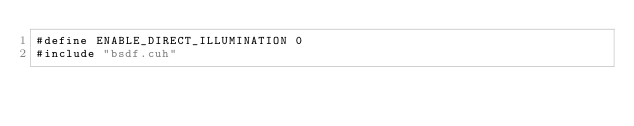Convert code to text. <code><loc_0><loc_0><loc_500><loc_500><_Cuda_>#define ENABLE_DIRECT_ILLUMINATION 0
#include "bsdf.cuh"</code> 